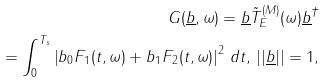Convert formula to latex. <formula><loc_0><loc_0><loc_500><loc_500>G ( \underline { b } , \omega ) = \underline { b } { \tilde { T } _ { E } } ^ { ( M ) } ( \omega ) \underline { b } ^ { \dagger } \\ = \int _ { 0 } ^ { T _ { s } } \left | b _ { 0 } F _ { 1 } ( t , \omega ) + b _ { 1 } F _ { 2 } ( t , \omega ) \right | ^ { 2 } \, d t , \, | | \underline { b } | | = 1 ,</formula> 